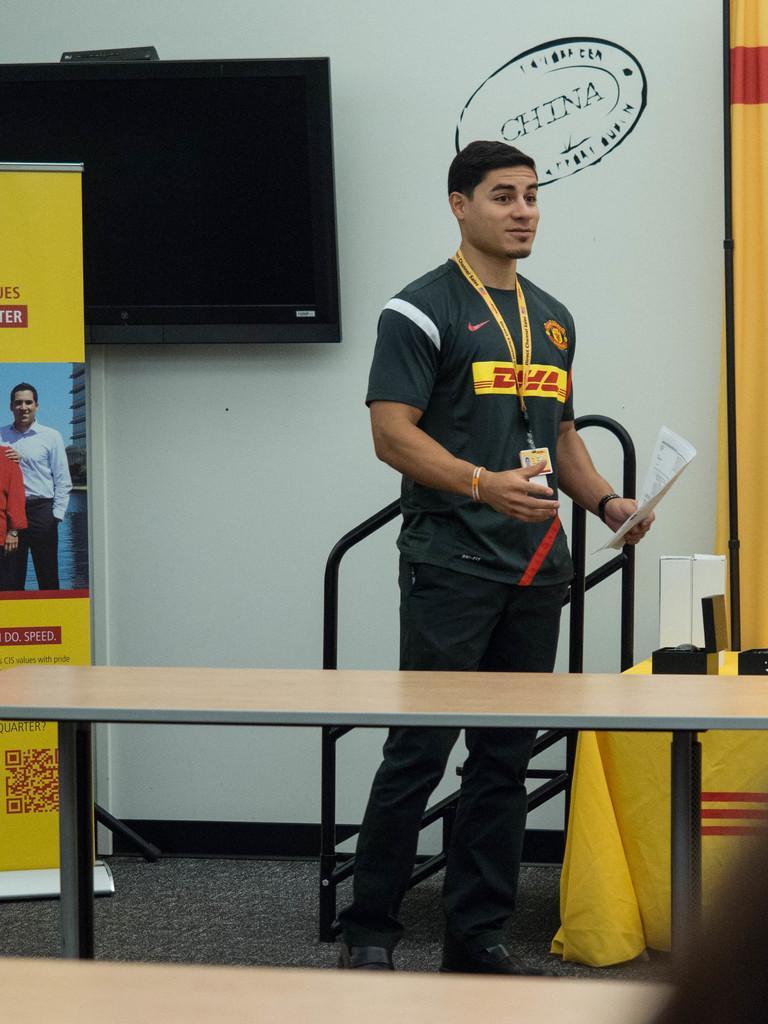Please provide a concise description of this image. In this image I can see a person wearing a t-shirt, pant and shoes Standing and holding few papers in his hand, I can see a table. in the background i can a banner,a television and the wall. 